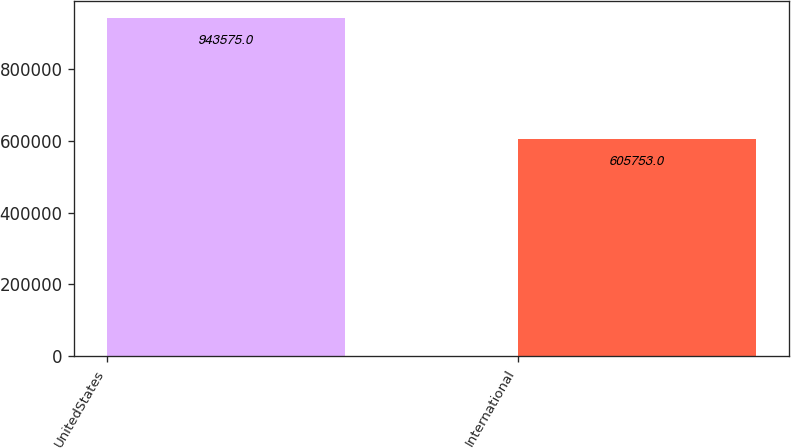Convert chart. <chart><loc_0><loc_0><loc_500><loc_500><bar_chart><fcel>UnitedStates<fcel>International<nl><fcel>943575<fcel>605753<nl></chart> 